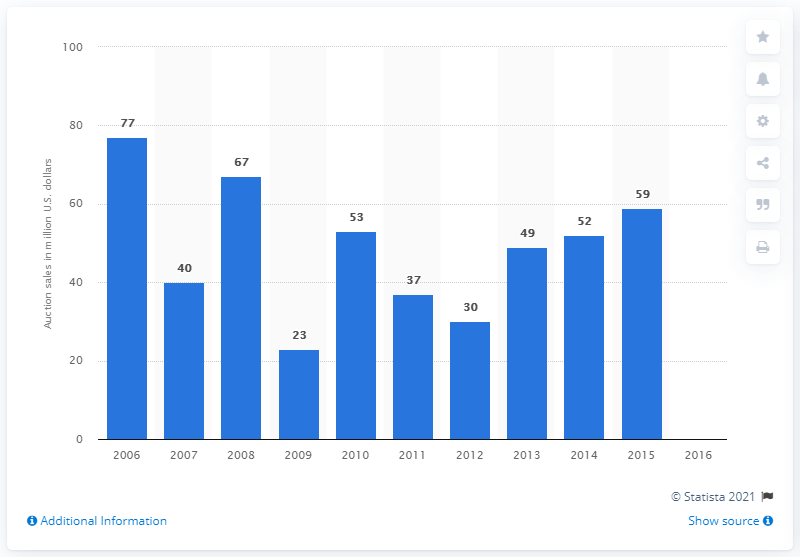Give some essential details in this illustration. In 2015, there were 59 auction sales of modern and contemporary art in India. 